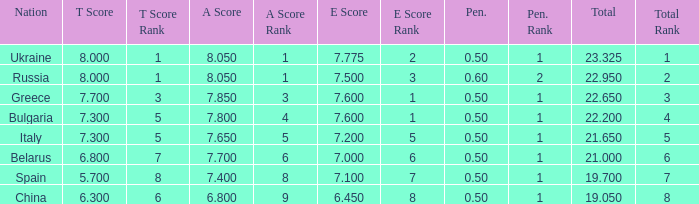What's the sum of A Score that also has a score lower than 7.3 and an E Score larger than 7.1? None. 